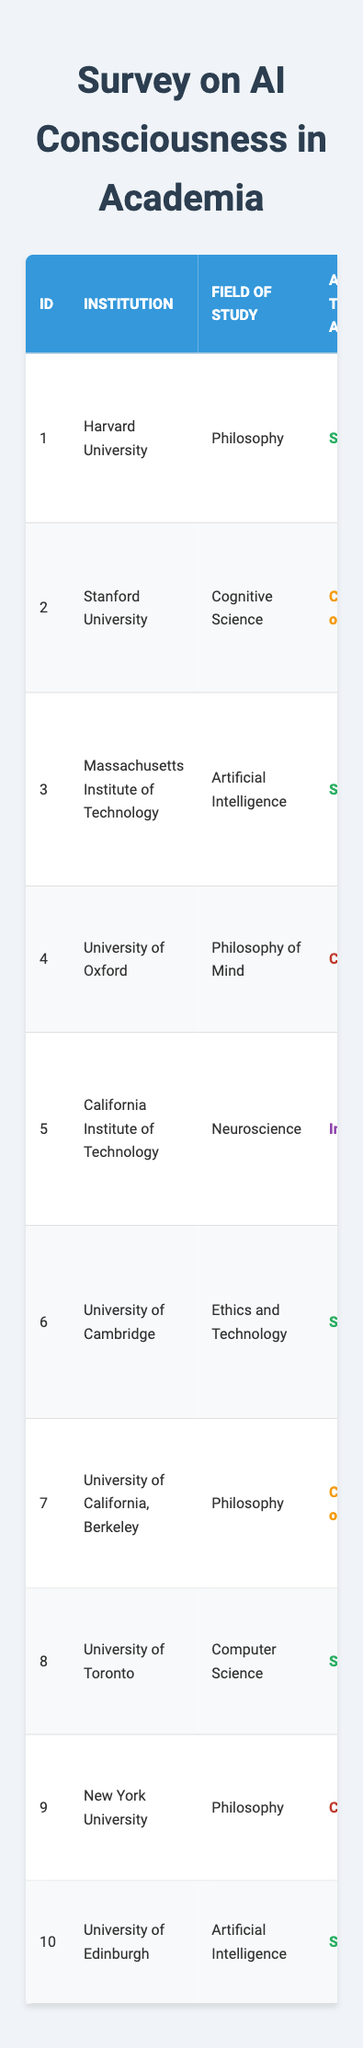What is the most common attitude towards AI in this survey? Looking at the table, the attitudes are categorized as Supportive, Cautiously optimistic, Critical, and Intrigued. Count each category: 5 Supportive, 3 Cautiously optimistic, 3 Critical, 1 Intrigued. The most common attitude is Supportive with 5 responses.
Answer: Supportive How many respondents believe AI consciousness is Skeptical? The table directly lists the belief in AI consciousness for each respondent. By scanning the data, we find that 3 respondents have a Skeptical belief in AI consciousness.
Answer: 3 Which institution has the highest years of experience among respondents? To identify the highest years of experience, compare the years across all respondents in the table. The highest value is indicated by respondent 9 from New York University with 30 years.
Answer: New York University Is there a correlation between attitude towards AI and belief in AI consciousness? To assess correlation, examine the respondents' attitudes and their corresponding beliefs. Each attitude doesn't definitively align with one belief; for example, both supportive and critical attitudes appear in multiple belief categories, suggesting no clear correlation.
Answer: No What are the years of experience of respondents who are Cautiously optimistic? The table shows 3 respondents with a Cautiously optimistic attitude. Their years of experience are 20 (Stanford), 25 (UC Berkeley). Add these together: 20 + 25 = 45 years.
Answer: 45 years How many respondents prioritize the importance of consciousness as "High"? Check the table for the importance of consciousness. The responses that designate it as High appear for 3 respondents: Harvard, California Institute of Technology, and University of Cambridge.
Answer: 3 Among those opposed to AI consciousness, how many have an essential importance of consciousness? Looking through respondents who are Opposed, we find 2 individuals (Oxford and NYU) asserting it as essential. Thus, it accounts for both respondents.
Answer: 2 What is the average years of experience of respondents who are Supportive of AI? The supportive respondents include 5 individuals. Their years of experience are 15, 10, 5, 18, and 22. Calculation: (15 + 10 + 5 + 18 + 22) = 70, so the average is 70 / 5 = 14.
Answer: 14 How many institutions represent the field of Philosophy? Scanning the table reveals that Philosophy is represented by Harvard, Oxford, and New York University, thus totaling 3 institutions.
Answer: 3 Is any respondent from the field of Neuroscience critical of AI? In reviewing the data, the respondent from California Institute of Technology (Neuroscience) shows an Intrigued attitude but is neither critical nor supportive of AI. Hence, no respondents from Neuroscience are critical.
Answer: No 